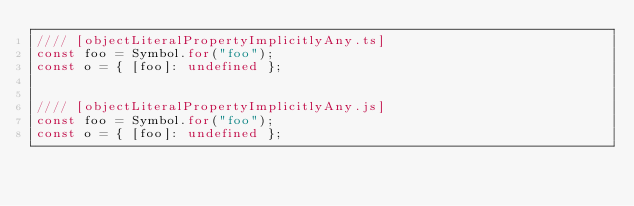Convert code to text. <code><loc_0><loc_0><loc_500><loc_500><_JavaScript_>//// [objectLiteralPropertyImplicitlyAny.ts]
const foo = Symbol.for("foo");
const o = { [foo]: undefined };


//// [objectLiteralPropertyImplicitlyAny.js]
const foo = Symbol.for("foo");
const o = { [foo]: undefined };
</code> 